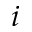<formula> <loc_0><loc_0><loc_500><loc_500>i</formula> 